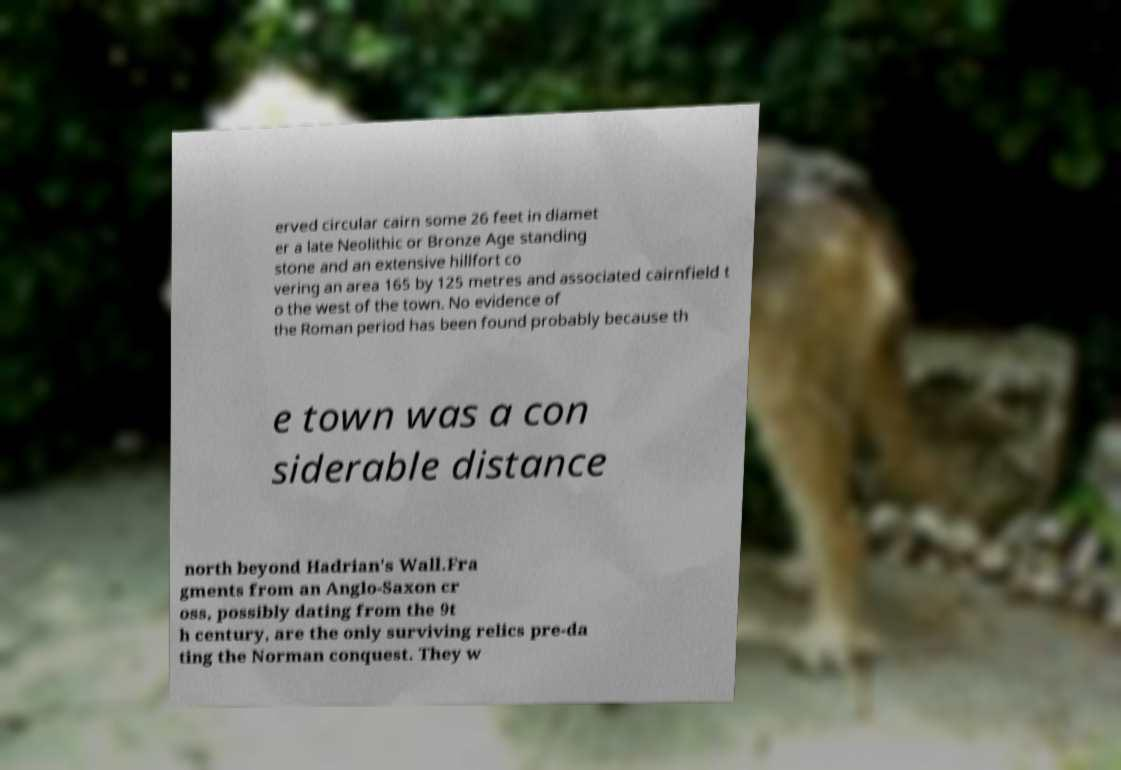There's text embedded in this image that I need extracted. Can you transcribe it verbatim? erved circular cairn some 26 feet in diamet er a late Neolithic or Bronze Age standing stone and an extensive hillfort co vering an area 165 by 125 metres and associated cairnfield t o the west of the town. No evidence of the Roman period has been found probably because th e town was a con siderable distance north beyond Hadrian's Wall.Fra gments from an Anglo-Saxon cr oss, possibly dating from the 9t h century, are the only surviving relics pre-da ting the Norman conquest. They w 